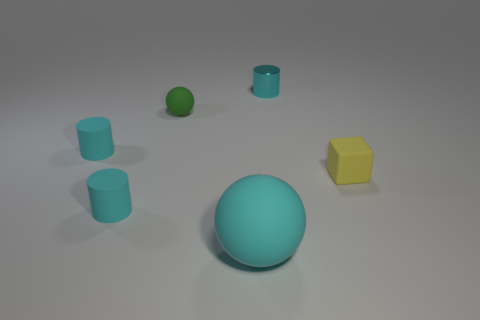How many cyan cylinders must be subtracted to get 1 cyan cylinders? 2 Subtract all cyan rubber cylinders. How many cylinders are left? 1 Add 2 tiny purple rubber cylinders. How many objects exist? 8 Subtract all green spheres. How many spheres are left? 1 Add 5 small rubber balls. How many small rubber balls exist? 6 Subtract 0 gray cylinders. How many objects are left? 6 Subtract all cubes. How many objects are left? 5 Subtract 2 spheres. How many spheres are left? 0 Subtract all blue spheres. Subtract all red cylinders. How many spheres are left? 2 Subtract all matte cylinders. Subtract all cyan matte spheres. How many objects are left? 3 